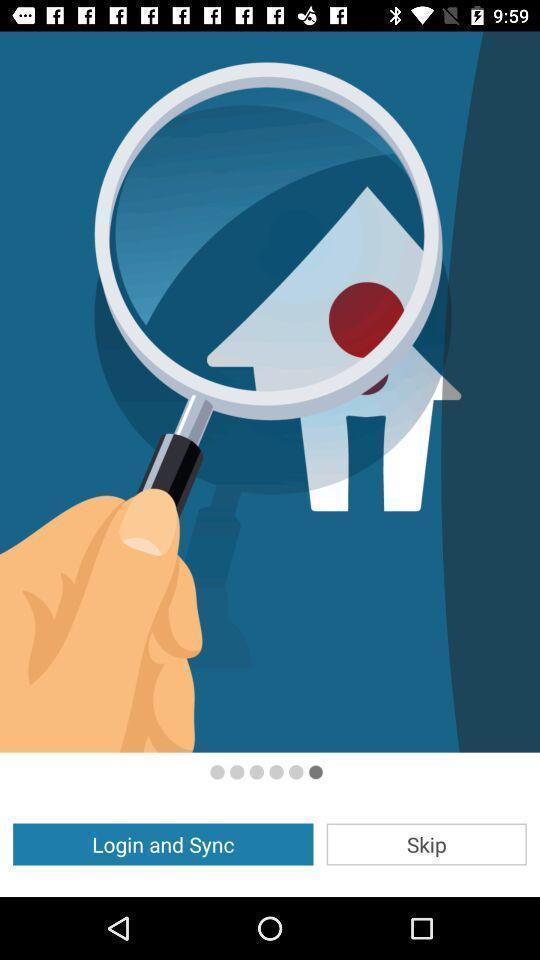Summarize the information in this screenshot. Welcome page showing login options. 